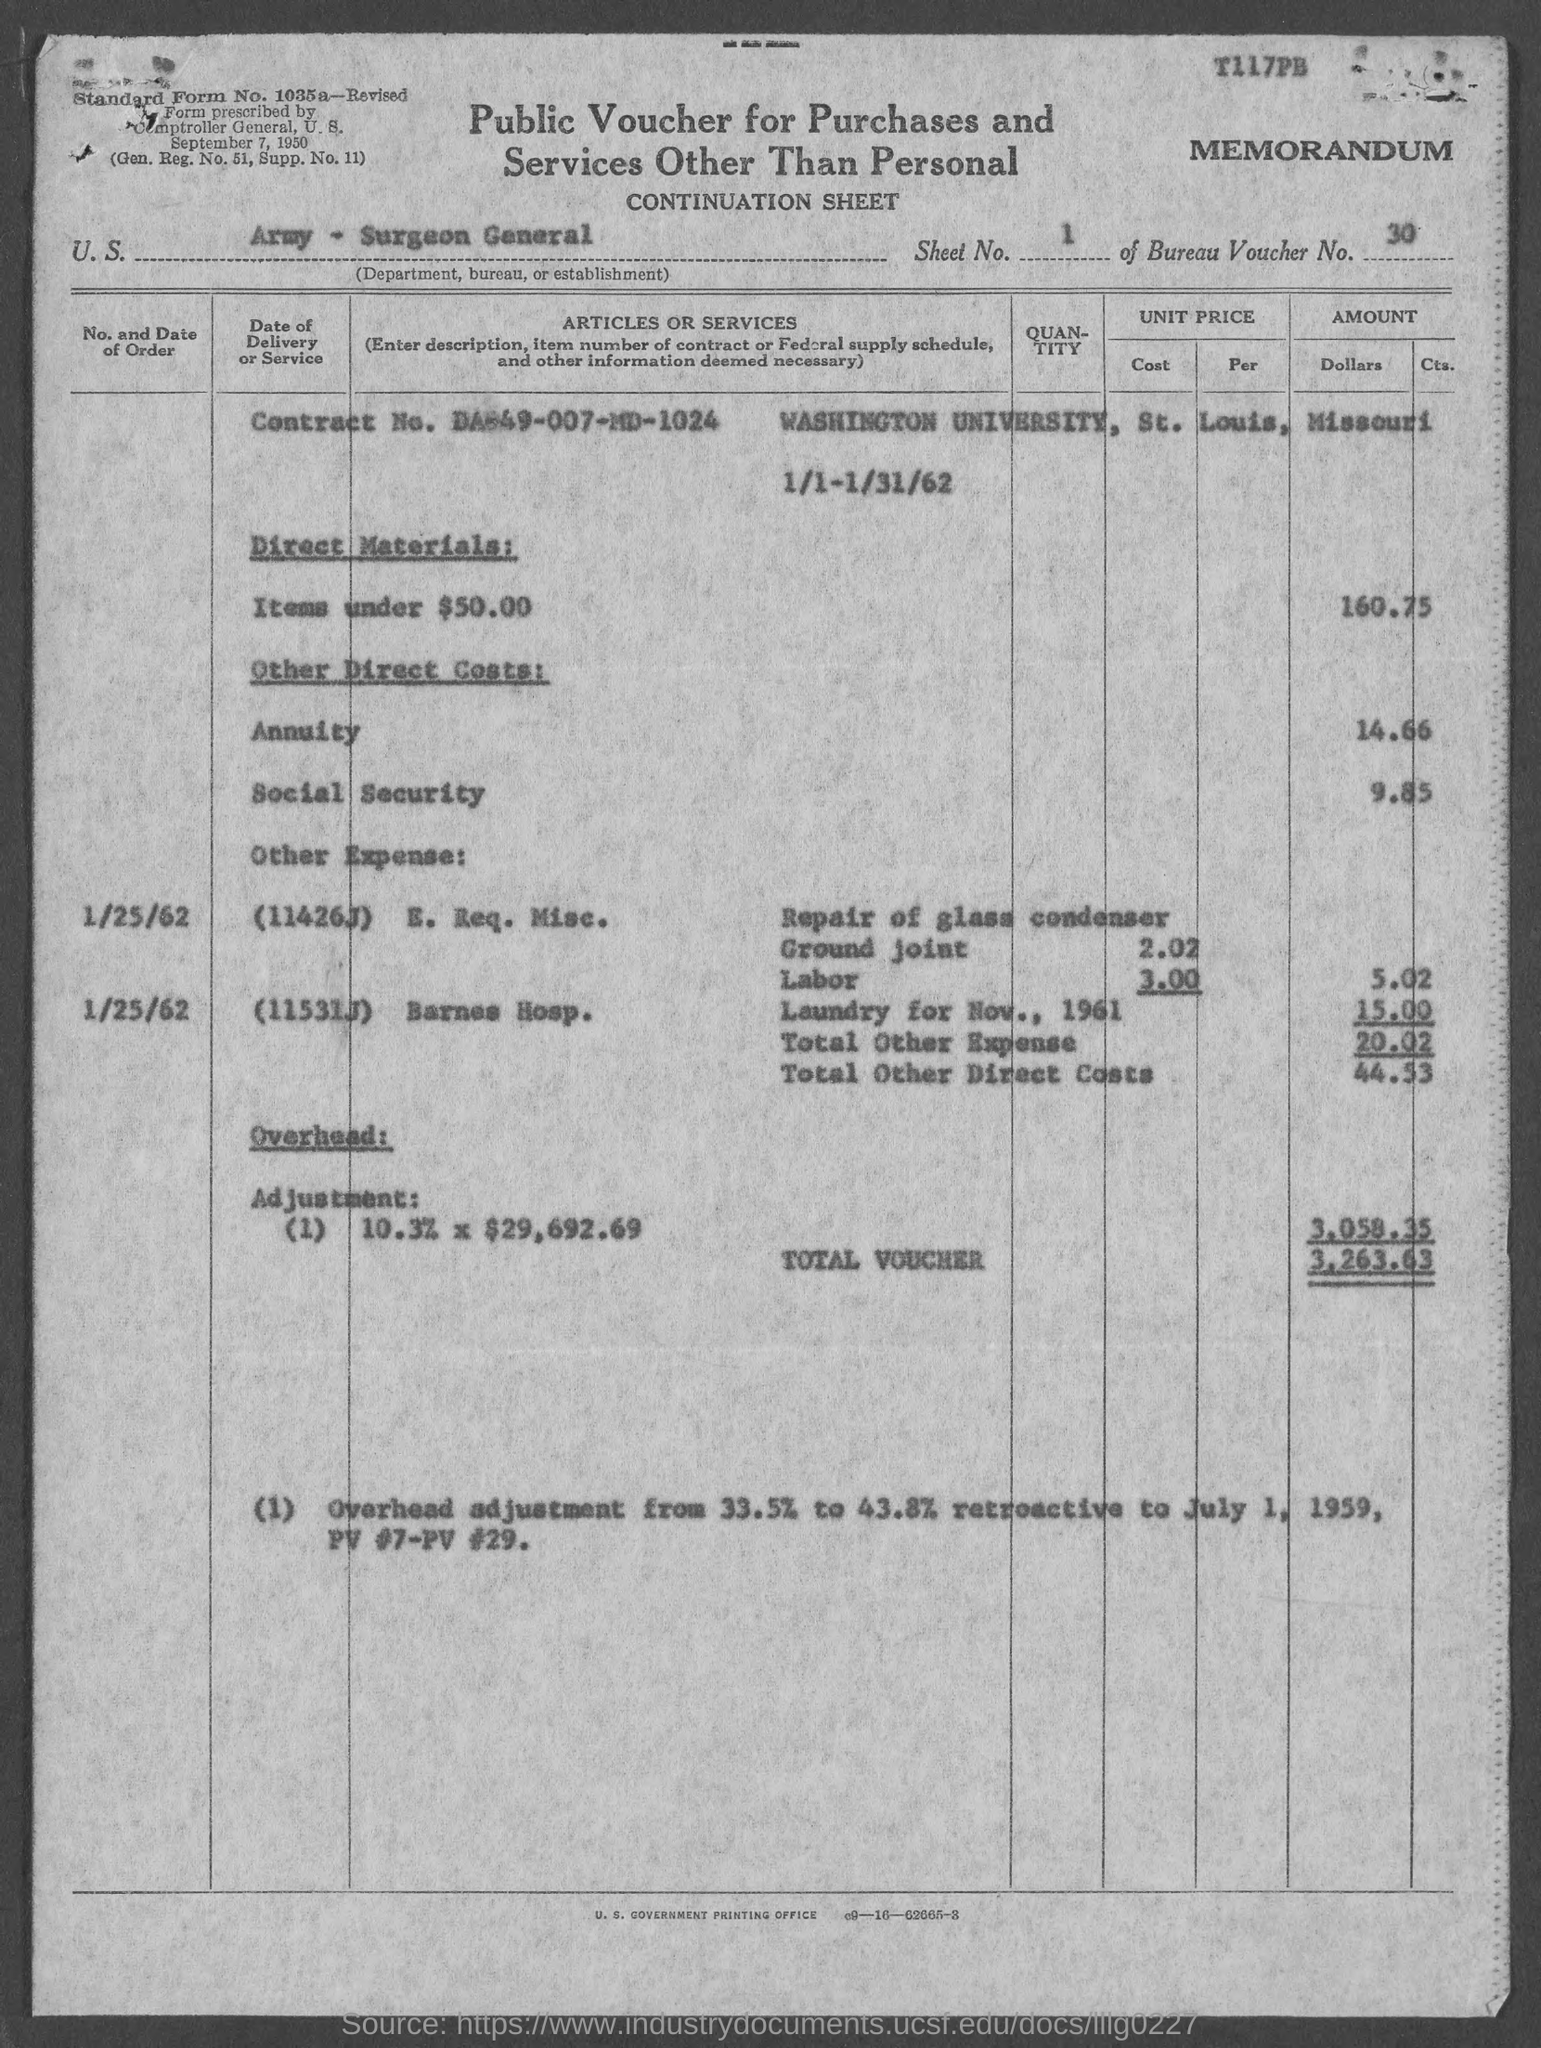What is the sheet no.?
Offer a terse response. 1. What is the bureau voucher no.?
Offer a terse response. 30. What is the standard form no.?
Your response must be concise. 1035a. What is the contract no.?
Your response must be concise. Da-49-007-md-1024. 